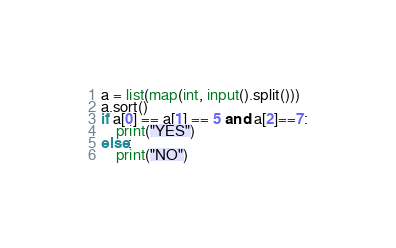<code> <loc_0><loc_0><loc_500><loc_500><_Python_>a = list(map(int, input().split()))
a.sort()
if a[0] == a[1] == 5 and a[2]==7:
    print("YES")
else:
    print("NO") </code> 